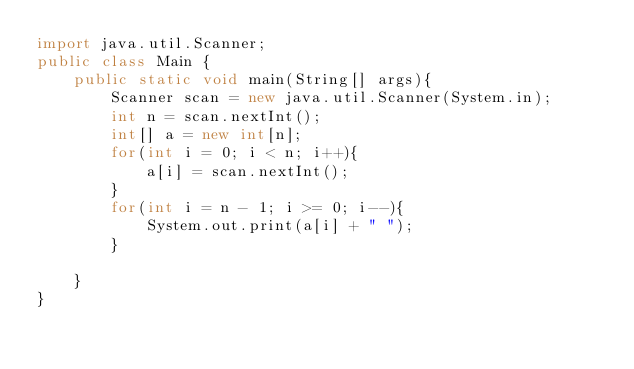<code> <loc_0><loc_0><loc_500><loc_500><_Java_>import java.util.Scanner;
public class Main {
    public static void main(String[] args){
        Scanner scan = new java.util.Scanner(System.in);
        int n = scan.nextInt();
        int[] a = new int[n];
        for(int i = 0; i < n; i++){
            a[i] = scan.nextInt();
        }
        for(int i = n - 1; i >= 0; i--){
            System.out.print(a[i] + " ");
        }
        
    }
}</code> 